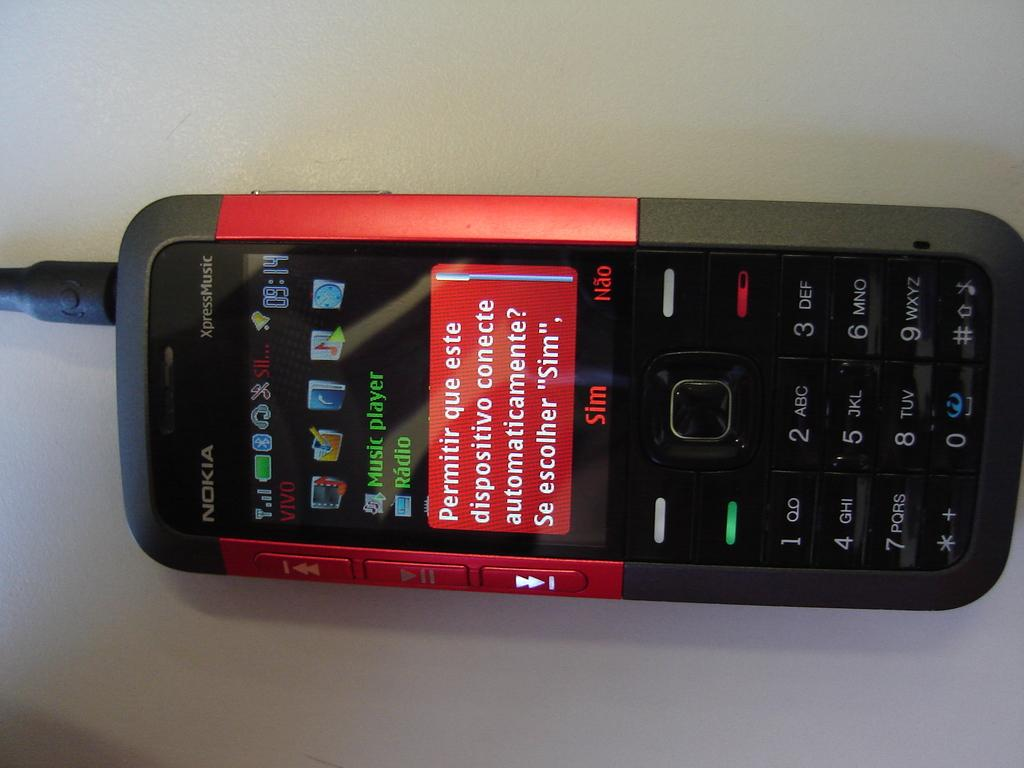<image>
Relay a brief, clear account of the picture shown. The Slim brand cell phone has permissions listed in Spanish. 